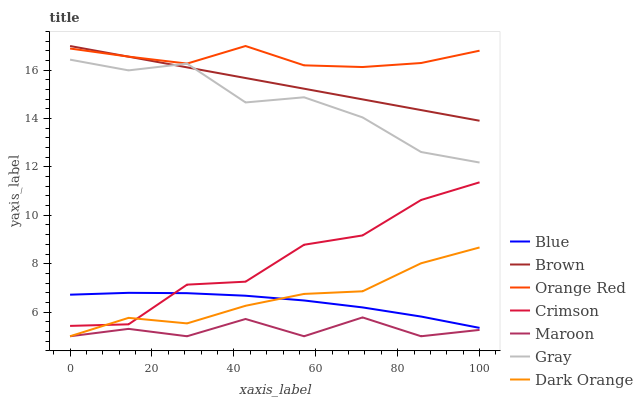Does Maroon have the minimum area under the curve?
Answer yes or no. Yes. Does Orange Red have the maximum area under the curve?
Answer yes or no. Yes. Does Brown have the minimum area under the curve?
Answer yes or no. No. Does Brown have the maximum area under the curve?
Answer yes or no. No. Is Brown the smoothest?
Answer yes or no. Yes. Is Crimson the roughest?
Answer yes or no. Yes. Is Gray the smoothest?
Answer yes or no. No. Is Gray the roughest?
Answer yes or no. No. Does Maroon have the lowest value?
Answer yes or no. Yes. Does Brown have the lowest value?
Answer yes or no. No. Does Orange Red have the highest value?
Answer yes or no. Yes. Does Gray have the highest value?
Answer yes or no. No. Is Maroon less than Crimson?
Answer yes or no. Yes. Is Brown greater than Maroon?
Answer yes or no. Yes. Does Brown intersect Orange Red?
Answer yes or no. Yes. Is Brown less than Orange Red?
Answer yes or no. No. Is Brown greater than Orange Red?
Answer yes or no. No. Does Maroon intersect Crimson?
Answer yes or no. No. 